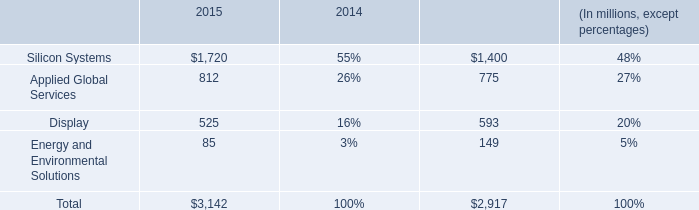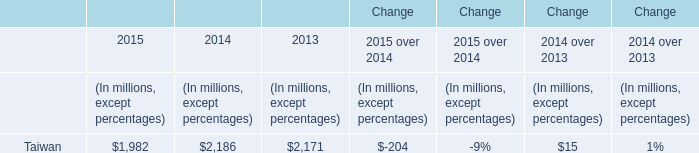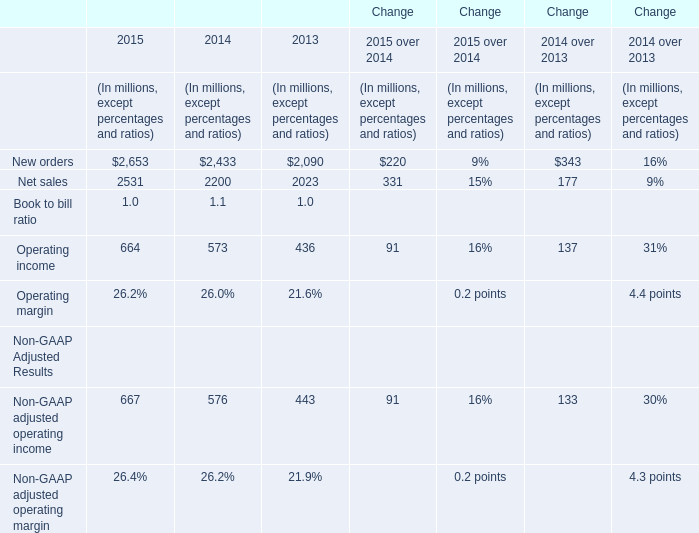what is the growth rate in the segment of display from 2014 to 2015? 
Computations: ((525 - 593) / 593)
Answer: -0.11467. 